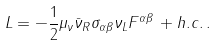Convert formula to latex. <formula><loc_0><loc_0><loc_500><loc_500>L = - \frac { 1 } { 2 } \mu _ { \nu } \bar { \nu } _ { R } \sigma _ { \alpha \beta } \nu _ { L } F ^ { \alpha \beta } \, + h . c . \, .</formula> 